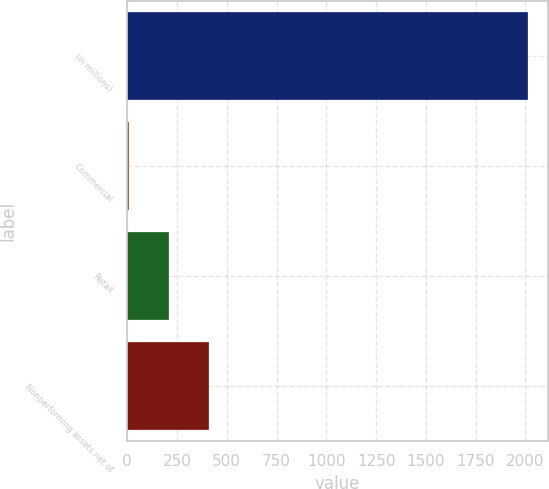Convert chart to OTSL. <chart><loc_0><loc_0><loc_500><loc_500><bar_chart><fcel>(in millions)<fcel>Commercial<fcel>Retail<fcel>Nonperforming assets net of<nl><fcel>2013<fcel>10<fcel>210.3<fcel>410.6<nl></chart> 